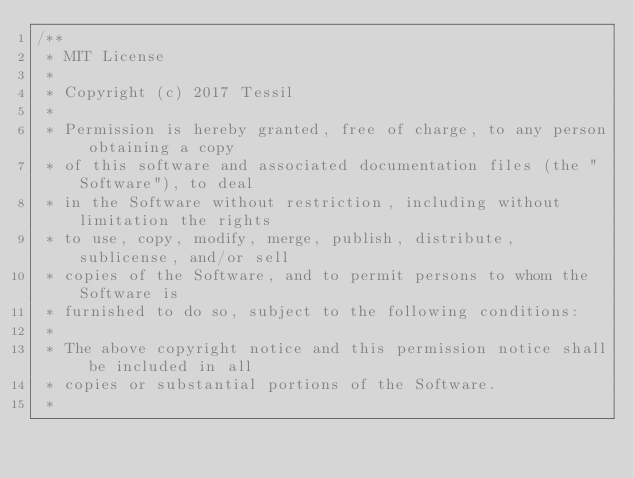Convert code to text. <code><loc_0><loc_0><loc_500><loc_500><_C_>/**
 * MIT License
 * 
 * Copyright (c) 2017 Tessil
 * 
 * Permission is hereby granted, free of charge, to any person obtaining a copy
 * of this software and associated documentation files (the "Software"), to deal
 * in the Software without restriction, including without limitation the rights
 * to use, copy, modify, merge, publish, distribute, sublicense, and/or sell
 * copies of the Software, and to permit persons to whom the Software is
 * furnished to do so, subject to the following conditions:
 * 
 * The above copyright notice and this permission notice shall be included in all
 * copies or substantial portions of the Software.
 * </code> 